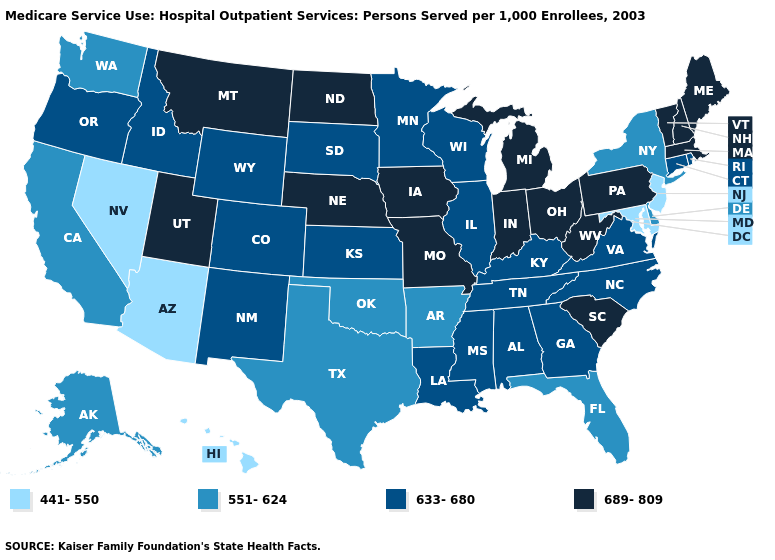What is the value of Oregon?
Give a very brief answer. 633-680. What is the value of Massachusetts?
Write a very short answer. 689-809. Which states have the lowest value in the USA?
Quick response, please. Arizona, Hawaii, Maryland, Nevada, New Jersey. Which states have the lowest value in the USA?
Give a very brief answer. Arizona, Hawaii, Maryland, Nevada, New Jersey. What is the value of Hawaii?
Quick response, please. 441-550. Which states have the lowest value in the MidWest?
Be succinct. Illinois, Kansas, Minnesota, South Dakota, Wisconsin. Does the first symbol in the legend represent the smallest category?
Keep it brief. Yes. What is the value of West Virginia?
Short answer required. 689-809. Name the states that have a value in the range 689-809?
Quick response, please. Indiana, Iowa, Maine, Massachusetts, Michigan, Missouri, Montana, Nebraska, New Hampshire, North Dakota, Ohio, Pennsylvania, South Carolina, Utah, Vermont, West Virginia. What is the lowest value in states that border Mississippi?
Concise answer only. 551-624. What is the value of New Mexico?
Answer briefly. 633-680. Does Louisiana have a lower value than Nevada?
Write a very short answer. No. What is the value of Hawaii?
Write a very short answer. 441-550. What is the value of South Carolina?
Answer briefly. 689-809. Is the legend a continuous bar?
Be succinct. No. 